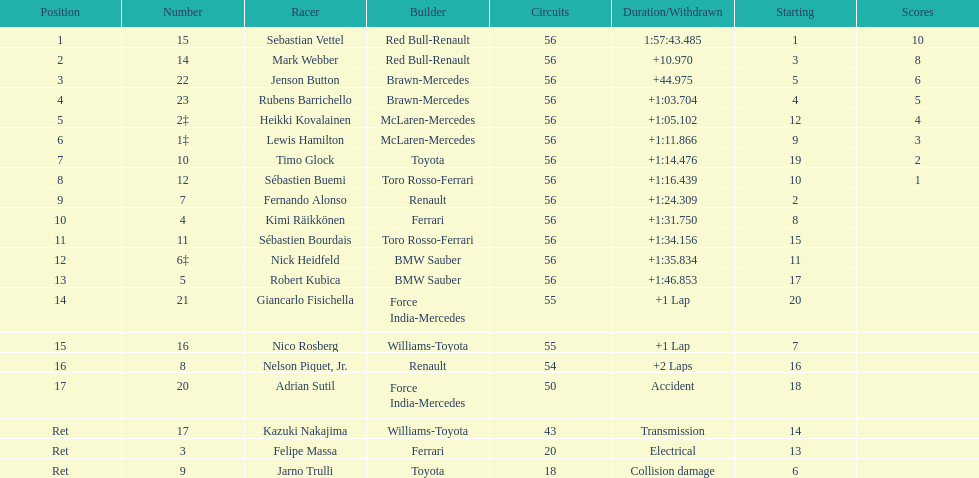What driver was last on the list? Jarno Trulli. 